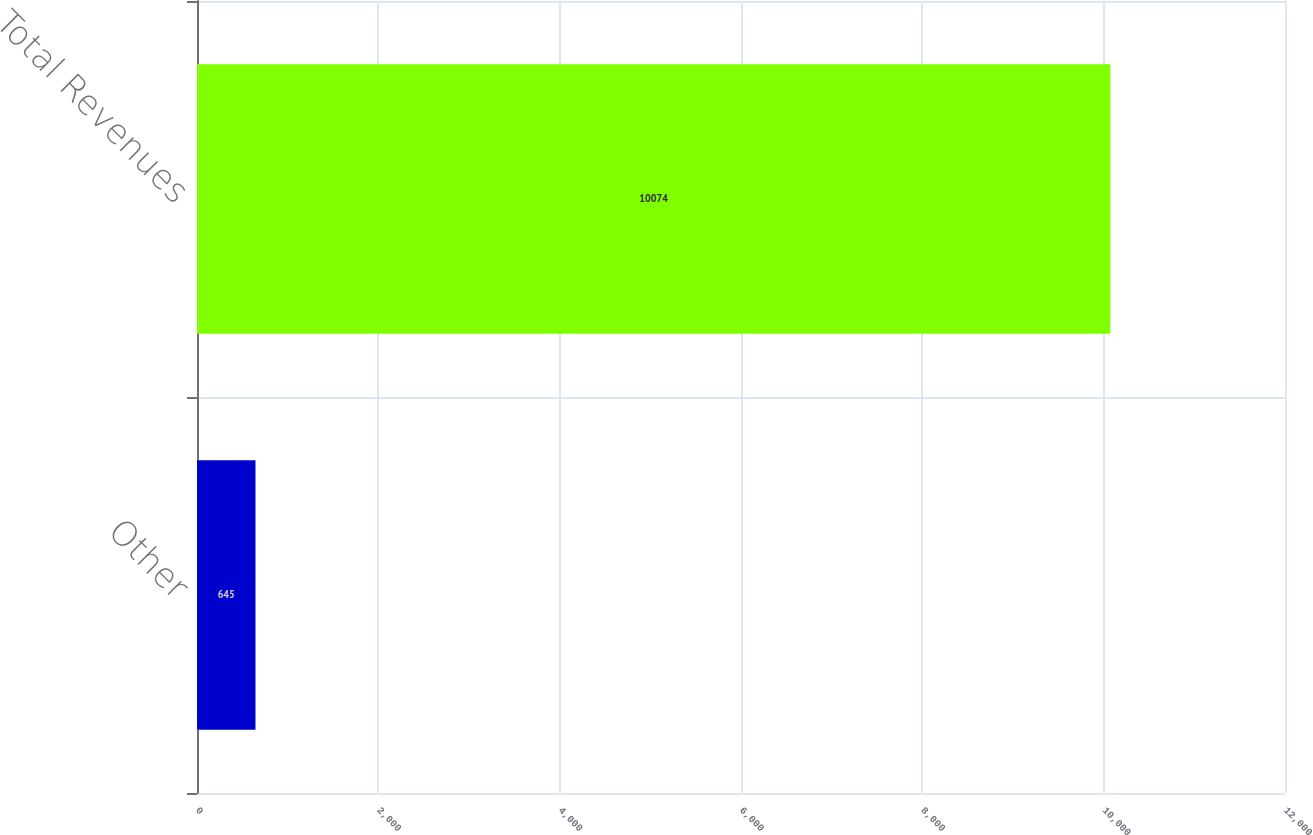<chart> <loc_0><loc_0><loc_500><loc_500><bar_chart><fcel>Other<fcel>Total Revenues<nl><fcel>645<fcel>10074<nl></chart> 